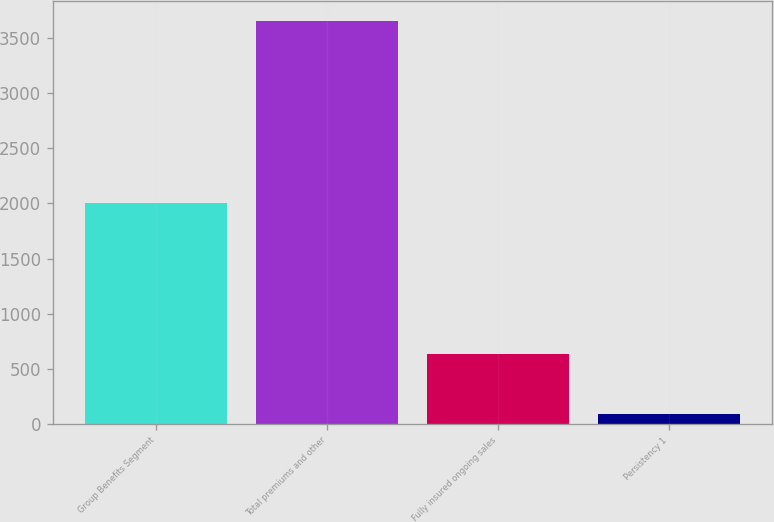<chart> <loc_0><loc_0><loc_500><loc_500><bar_chart><fcel>Group Benefits Segment<fcel>Total premiums and other<fcel>Fully insured ongoing sales<fcel>Persistency 1<nl><fcel>2004<fcel>3652<fcel>632<fcel>88<nl></chart> 